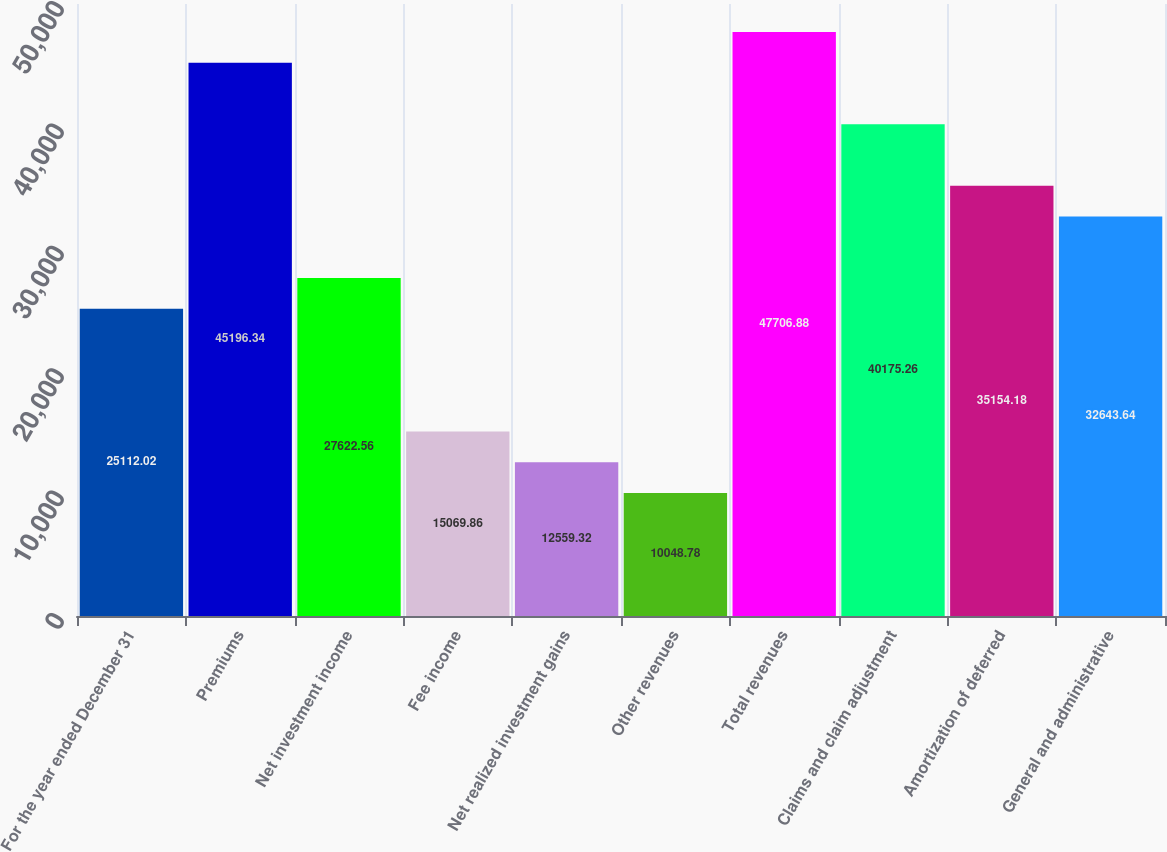Convert chart to OTSL. <chart><loc_0><loc_0><loc_500><loc_500><bar_chart><fcel>For the year ended December 31<fcel>Premiums<fcel>Net investment income<fcel>Fee income<fcel>Net realized investment gains<fcel>Other revenues<fcel>Total revenues<fcel>Claims and claim adjustment<fcel>Amortization of deferred<fcel>General and administrative<nl><fcel>25112<fcel>45196.3<fcel>27622.6<fcel>15069.9<fcel>12559.3<fcel>10048.8<fcel>47706.9<fcel>40175.3<fcel>35154.2<fcel>32643.6<nl></chart> 